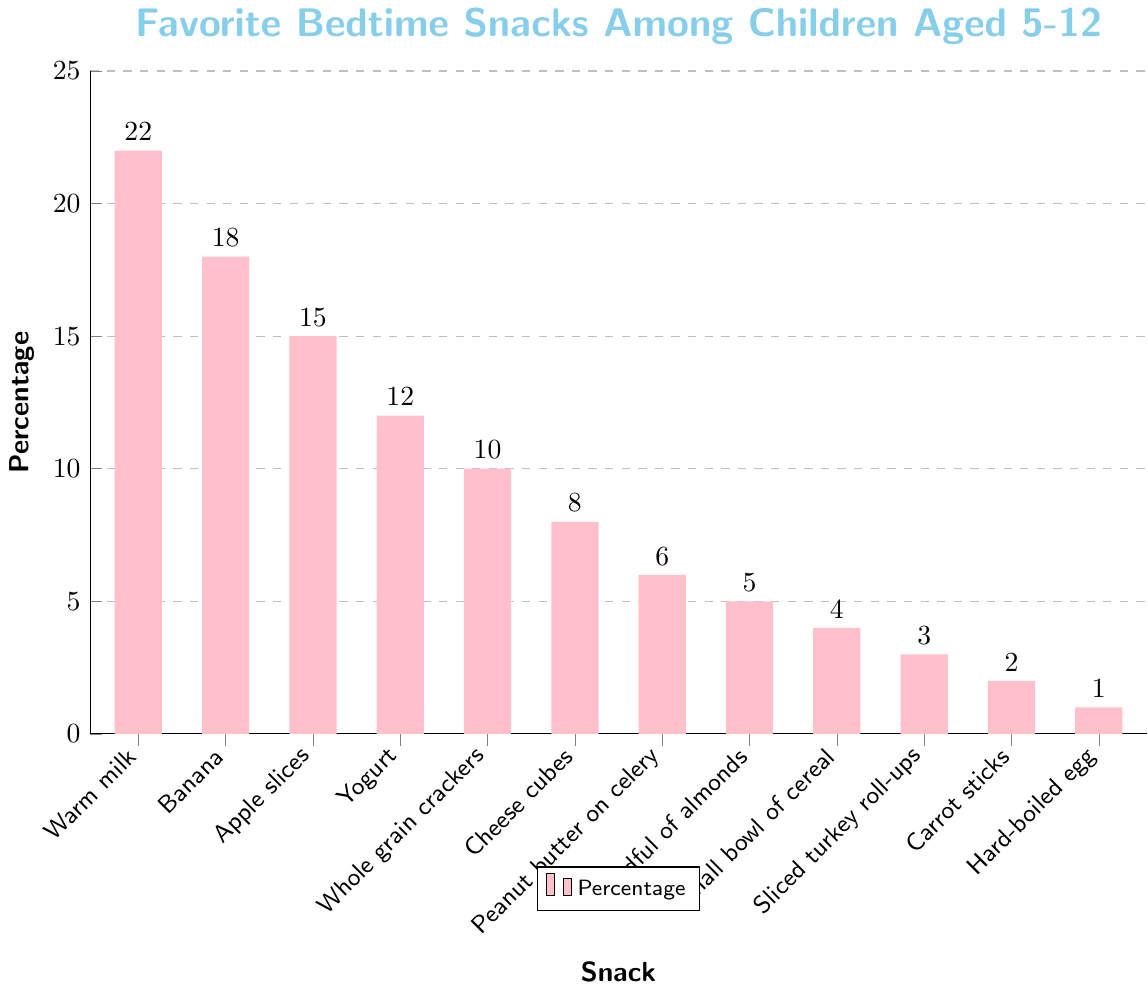Which bedtime snack is the most popular? To find the most popular bedtime snack, look for the snack with the highest bar. Warm milk has the highest bar, indicating it is the most popular.
Answer: Warm milk What percentage of children prefer apple slices over whole grain crackers? Identify the percentage values for apple slices and whole grain crackers from the chart. Apple slices = 15%, whole grain crackers = 10%. Then compute the difference: 15% - 10% = 5%.
Answer: 5% Which snack is less popular: carrot sticks or hard-boiled egg? Look at the height of the bars corresponding to carrot sticks and hard-boiled egg. The bar for hard-boiled egg is lower than that for carrot sticks.
Answer: Hard-boiled egg What is the total percentage of children who prefer banana, apple slices, and yogurt combined? Identify the percentages for banana, apple slices, and yogurt. Banana = 18%, apple slices = 15%, yogurt = 12%. Then add them together: 18% + 15% + 12% = 45%.
Answer: 45% How much more popular is warm milk compared to cheese cubes? Find the percentage values for warm milk and cheese cubes. Warm milk = 22%, cheese cubes = 8%. Compute the difference: 22% - 8% = 14%.
Answer: 14% Which snack is more popular: a small bowl of cereal or a handful of almonds? Compare the heights of the bars for a small bowl of cereal and a handful of almonds. The bar for a handful of almonds is higher than for a small bowl of cereal.
Answer: Handful of almonds What is the combined percentage of the two least favorite snacks? Identify the two snacks with the smallest bars. Carrot sticks = 2%, hard-boiled egg = 1%. Add them together: 2% + 1% = 3%.
Answer: 3% Is the percentage of children preferring yogurt more than double the percentage preferring a small bowl of cereal? Find the percentage values for yogurt and a small bowl of cereal. Yogurt = 12%, small bowl of cereal = 4%. Check if 12% > 2 * 4% = 8%. Yes, it is more.
Answer: Yes What is the difference in popularity between peanut butter on celery and sliced turkey roll-ups? Find the percentage values for peanut butter on celery and sliced turkey roll-ups. Peanut butter on celery = 6%, sliced turkey roll-ups = 3%. Compute the difference: 6% - 3% = 3%.
Answer: 3% Which has a higher percentage: whole grain crackers or cheese cubes? Compare the heights of the bars for whole grain crackers and cheese cubes. The bar for whole grain crackers is higher.
Answer: Whole grain crackers 